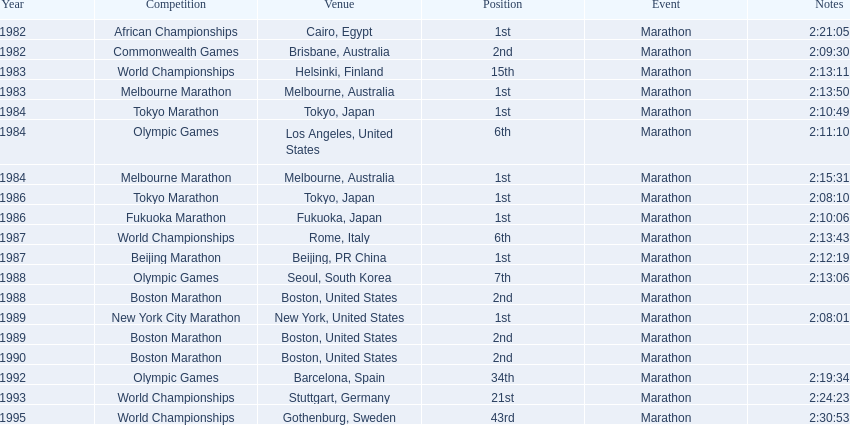What are the competitions? African Championships, Cairo, Egypt, Commonwealth Games, Brisbane, Australia, World Championships, Helsinki, Finland, Melbourne Marathon, Melbourne, Australia, Tokyo Marathon, Tokyo, Japan, Olympic Games, Los Angeles, United States, Melbourne Marathon, Melbourne, Australia, Tokyo Marathon, Tokyo, Japan, Fukuoka Marathon, Fukuoka, Japan, World Championships, Rome, Italy, Beijing Marathon, Beijing, PR China, Olympic Games, Seoul, South Korea, Boston Marathon, Boston, United States, New York City Marathon, New York, United States, Boston Marathon, Boston, United States, Boston Marathon, Boston, United States, Olympic Games, Barcelona, Spain, World Championships, Stuttgart, Germany, World Championships, Gothenburg, Sweden. Which ones occured in china? Beijing Marathon, Beijing, PR China. Which one is it? Beijing Marathon. 